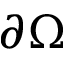<formula> <loc_0><loc_0><loc_500><loc_500>\partial \Omega</formula> 